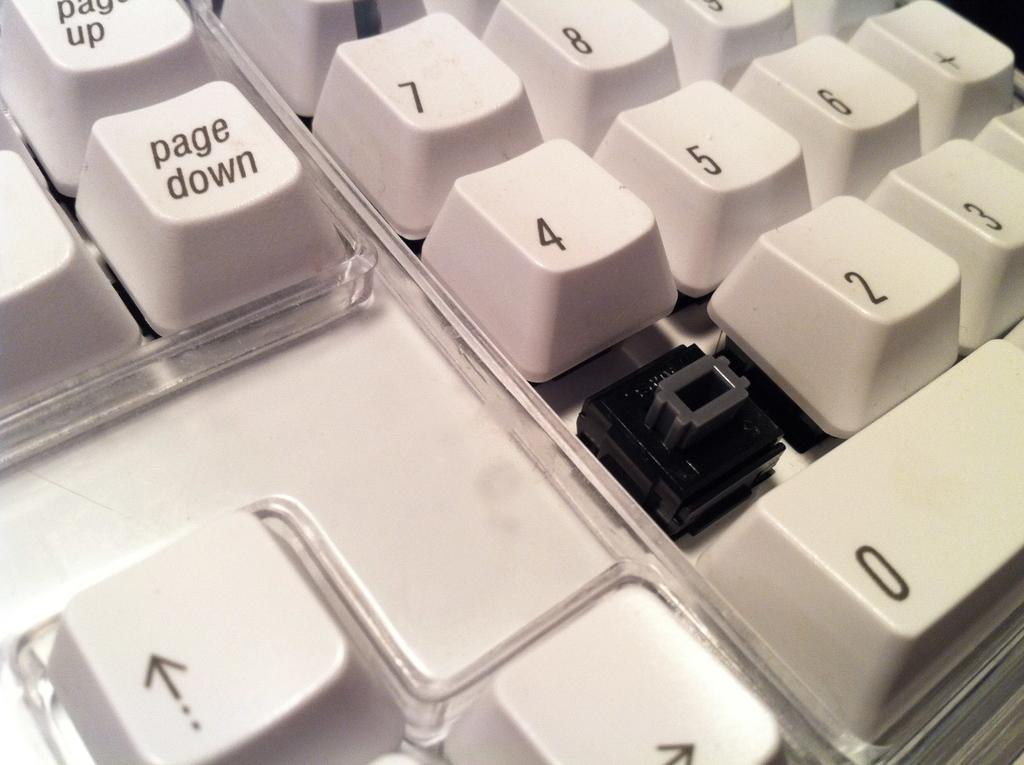<image>
Write a terse but informative summary of the picture. A white computer keyboard with the page down key in the center of the frame. 